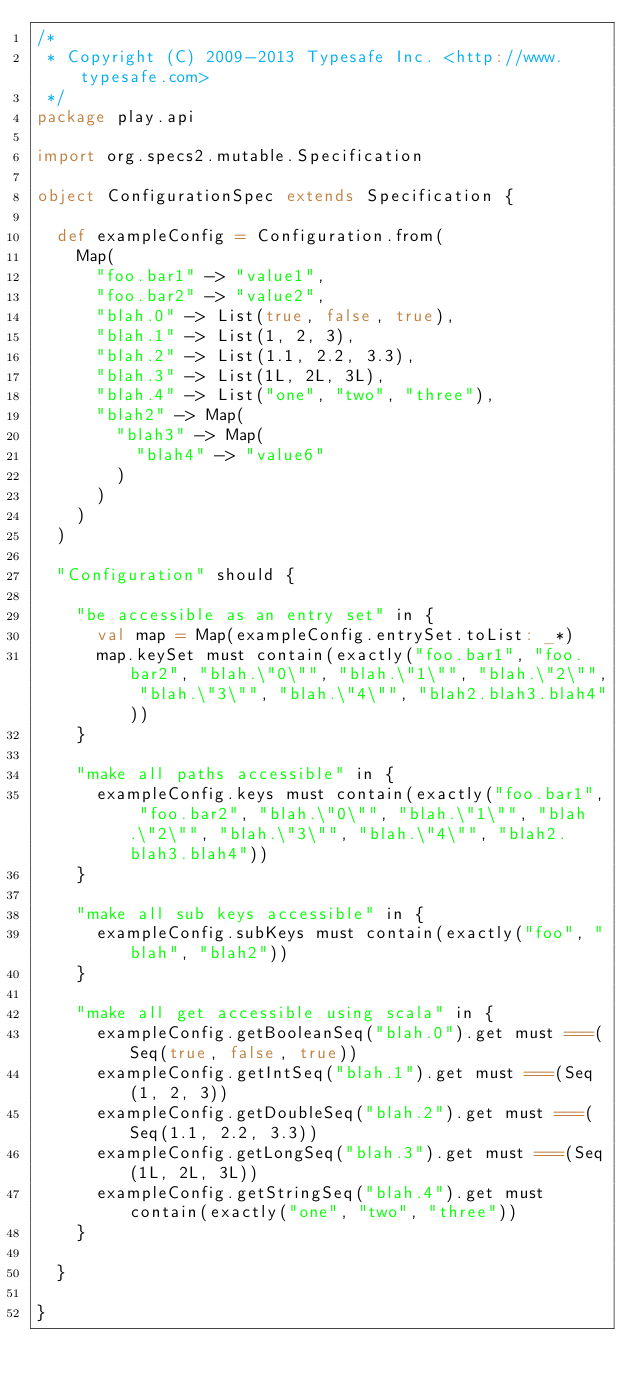Convert code to text. <code><loc_0><loc_0><loc_500><loc_500><_Scala_>/*
 * Copyright (C) 2009-2013 Typesafe Inc. <http://www.typesafe.com>
 */
package play.api

import org.specs2.mutable.Specification

object ConfigurationSpec extends Specification {

  def exampleConfig = Configuration.from(
    Map(
      "foo.bar1" -> "value1",
      "foo.bar2" -> "value2",
      "blah.0" -> List(true, false, true),
      "blah.1" -> List(1, 2, 3),
      "blah.2" -> List(1.1, 2.2, 3.3),
      "blah.3" -> List(1L, 2L, 3L),
      "blah.4" -> List("one", "two", "three"),
      "blah2" -> Map(
        "blah3" -> Map(
          "blah4" -> "value6"
        )
      )
    )
  )

  "Configuration" should {

    "be accessible as an entry set" in {
      val map = Map(exampleConfig.entrySet.toList: _*)
      map.keySet must contain(exactly("foo.bar1", "foo.bar2", "blah.\"0\"", "blah.\"1\"", "blah.\"2\"", "blah.\"3\"", "blah.\"4\"", "blah2.blah3.blah4"))
    }

    "make all paths accessible" in {
      exampleConfig.keys must contain(exactly("foo.bar1", "foo.bar2", "blah.\"0\"", "blah.\"1\"", "blah.\"2\"", "blah.\"3\"", "blah.\"4\"", "blah2.blah3.blah4"))
    }

    "make all sub keys accessible" in {
      exampleConfig.subKeys must contain(exactly("foo", "blah", "blah2"))
    }

    "make all get accessible using scala" in {
      exampleConfig.getBooleanSeq("blah.0").get must ===(Seq(true, false, true))
      exampleConfig.getIntSeq("blah.1").get must ===(Seq(1, 2, 3))
      exampleConfig.getDoubleSeq("blah.2").get must ===(Seq(1.1, 2.2, 3.3))
      exampleConfig.getLongSeq("blah.3").get must ===(Seq(1L, 2L, 3L))
      exampleConfig.getStringSeq("blah.4").get must contain(exactly("one", "two", "three"))
    }

  }

}
</code> 